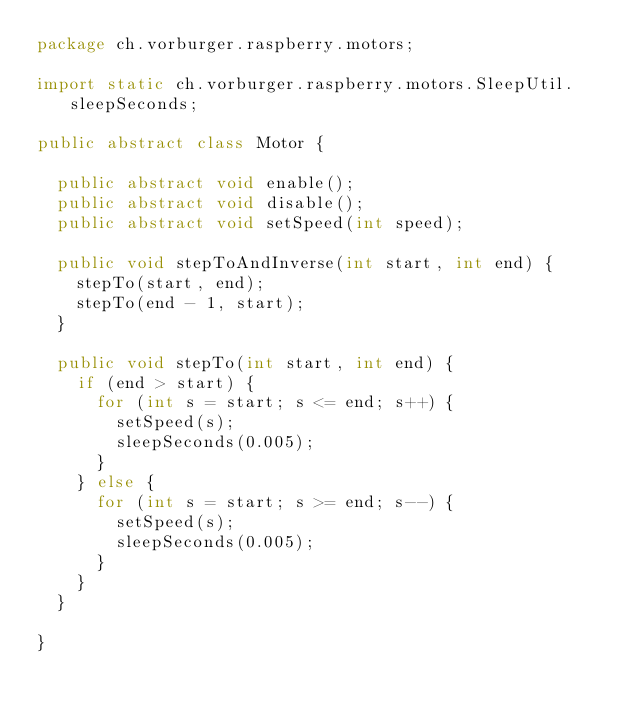<code> <loc_0><loc_0><loc_500><loc_500><_Java_>package ch.vorburger.raspberry.motors;

import static ch.vorburger.raspberry.motors.SleepUtil.sleepSeconds;

public abstract class Motor {

	public abstract void enable();
	public abstract void disable();
	public abstract void setSpeed(int speed);

	public void stepToAndInverse(int start, int end) {
		stepTo(start, end);
		stepTo(end - 1, start);
	}

	public void stepTo(int start, int end) {
		if (end > start) {
			for (int s = start; s <= end; s++) {
				setSpeed(s);
				sleepSeconds(0.005);
			}
		} else {
			for (int s = start; s >= end; s--) {
				setSpeed(s);
				sleepSeconds(0.005);
			}
		}
	}

}
</code> 